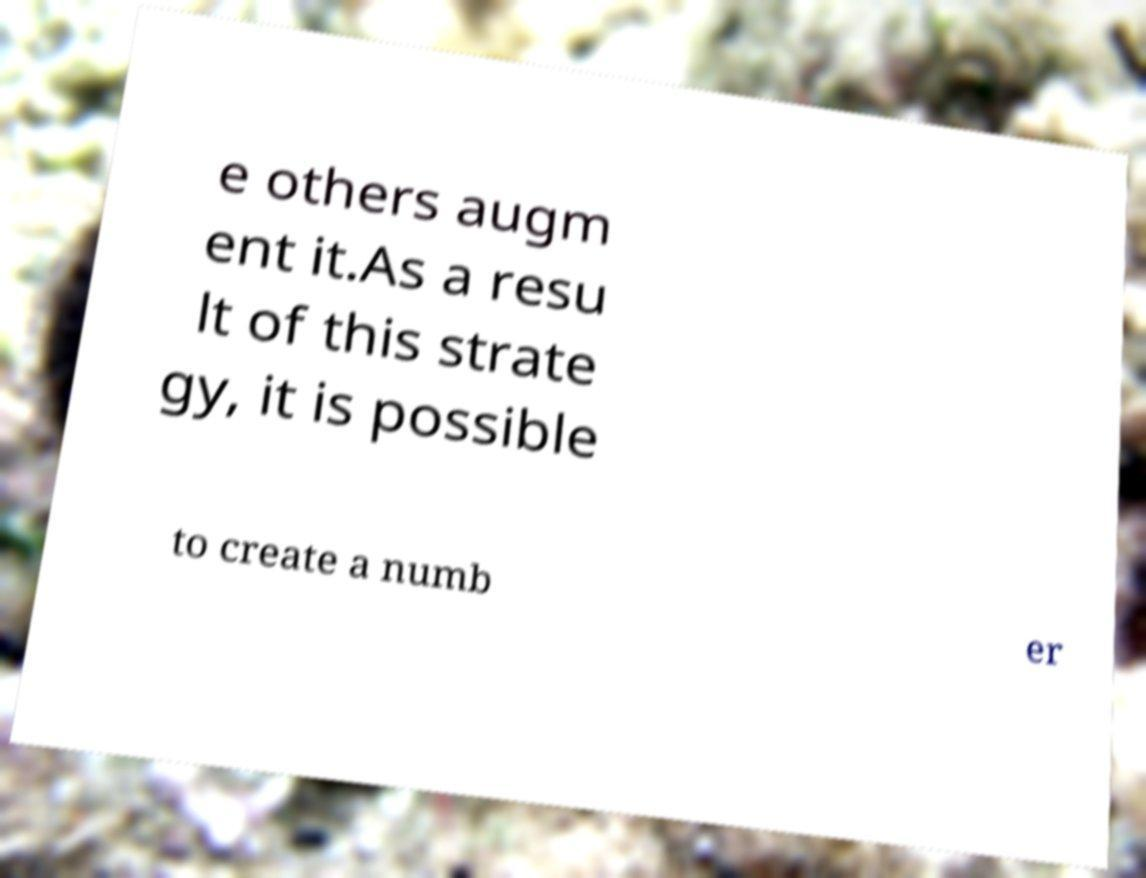Could you assist in decoding the text presented in this image and type it out clearly? e others augm ent it.As a resu lt of this strate gy, it is possible to create a numb er 